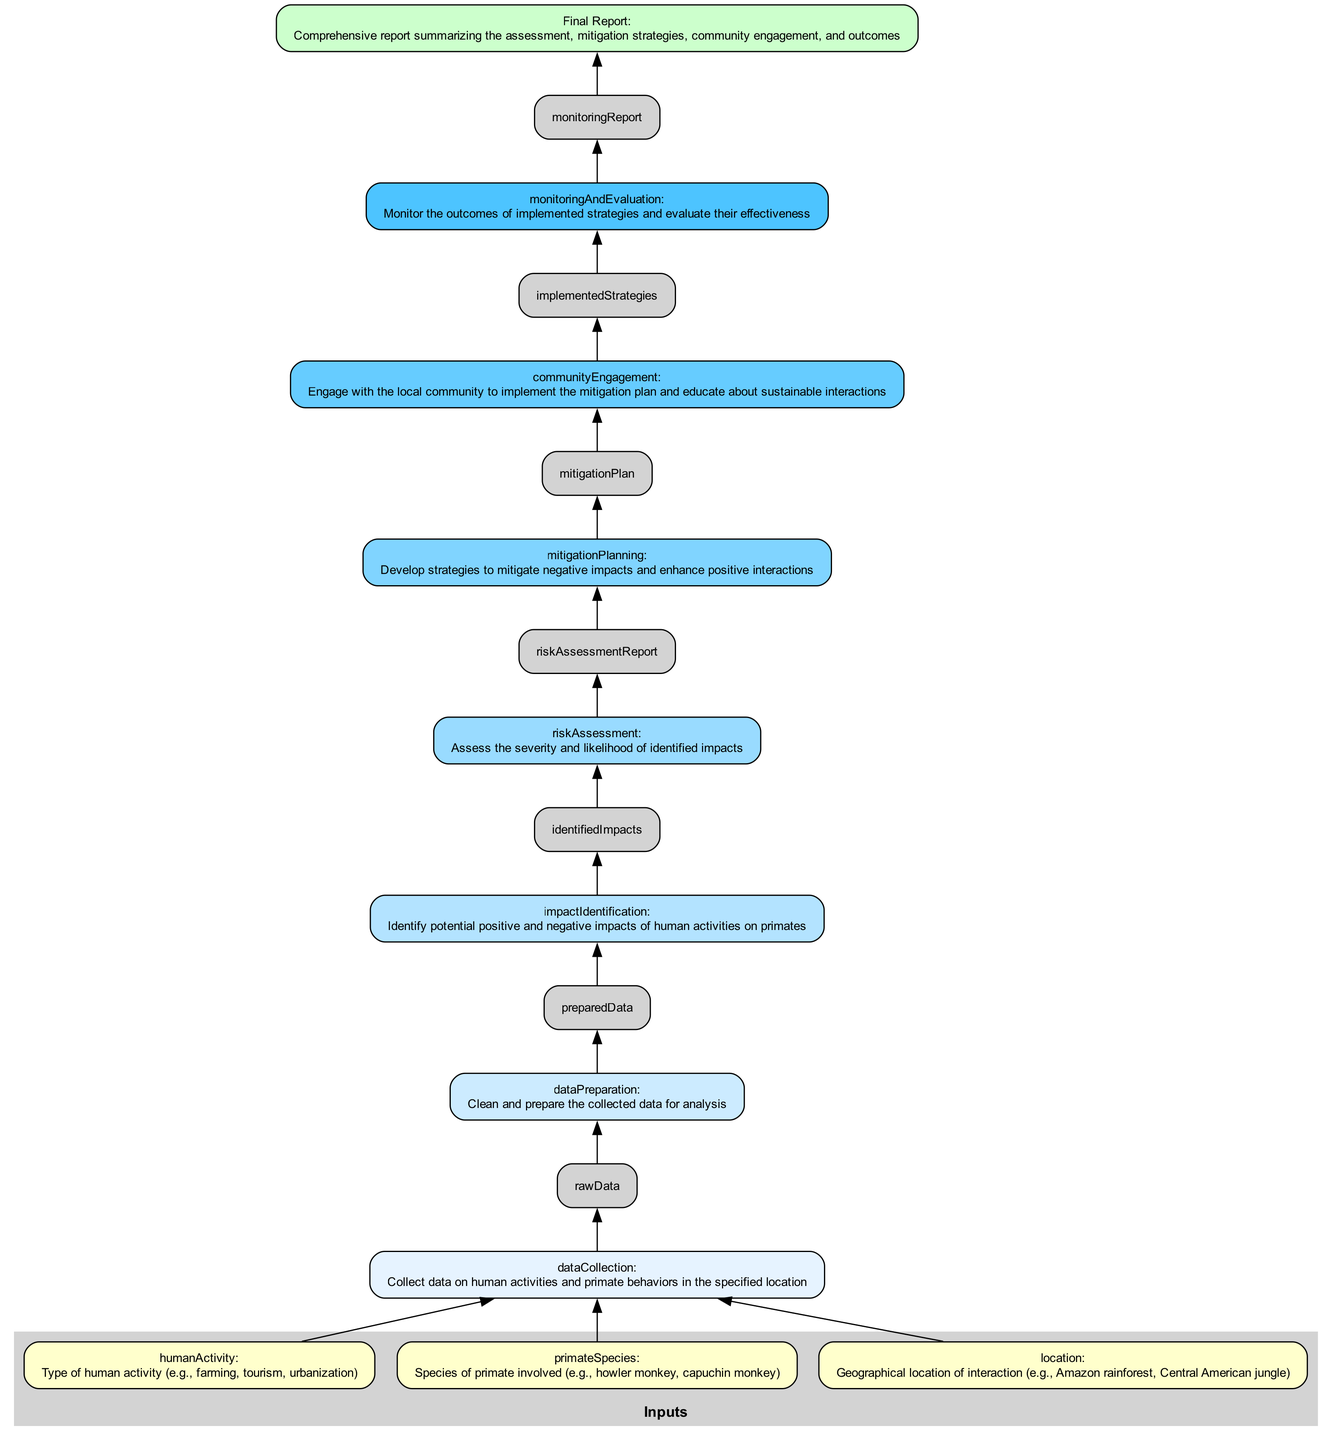What are the inputs to the assessment process? The inputs are listed as human activity, primate species, and location. These represent the essential data needed to begin the assessment process.
Answer: human activity, primate species, location How many steps are there in the assessment process? The assessment process comprises several steps, specifically seven, including data collection, data preparation, impact identification, risk assessment, mitigation planning, community engagement, and monitoring and evaluation.
Answer: seven Which step produces the risk assessment report? The risk assessment step produces the risk assessment report as its output. Following the impact identification step, it assesses the severity and likelihood of impacts, generating this report as an outcome.
Answer: risk assessment What is the final output of the process? The final output of the process, at the top of the flowchart, summarizes the entire assessment, including mitigation strategies and community engagement.
Answer: comprehensive report summarizing the assessment, mitigation strategies, community engagement, and outcomes What connects the data preparation step to the impact identification step? The data preparation step outputs the prepared data, which serves as the input for the subsequent impact identification step. The flow from prepared data to identified impacts indicates this connection.
Answer: prepared data Which steps have outputs that lead to further steps? All steps except for the last one, the final report, lead to further steps. The steps processing data contribute outputs that act as inputs for subsequent steps, allowing for a continuous flow in the assessment process until reaching the final report.
Answer: all steps except final report What is identified after the impact identification step? After the impact identification step, potential positive and negative impacts of human activities on primates are identified as the next significant outcome. This is essential in assessing the overall interaction.
Answer: identified impacts How does the community engagement step connect with its input? The community engagement step receives the mitigation plan as its input, indicating that the strategies developed to mitigate negative impacts are crucial for engaging the local community in sustainable practices based on the assessment findings.
Answer: mitigation plan Which color represents the risk assessment step? The risk assessment step uses one of the colors from the designated palette, specifically the same color used for other steps following the order of creation in the flowchart. It represents the stage of evaluating impacts.
Answer: #99DBFF 